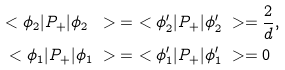Convert formula to latex. <formula><loc_0><loc_0><loc_500><loc_500>\ < \phi _ { 2 } | P _ { + } | \phi _ { 2 } \ > & = \ < \phi _ { 2 } ^ { \prime } | P _ { + } | \phi _ { 2 } ^ { \prime } \ > = \frac { 2 } { d } , \\ \ < \phi _ { 1 } | P _ { + } | \phi _ { 1 } \ > & = \ < \phi _ { 1 } ^ { \prime } | P _ { + } | \phi _ { 1 } ^ { \prime } \ > = 0</formula> 